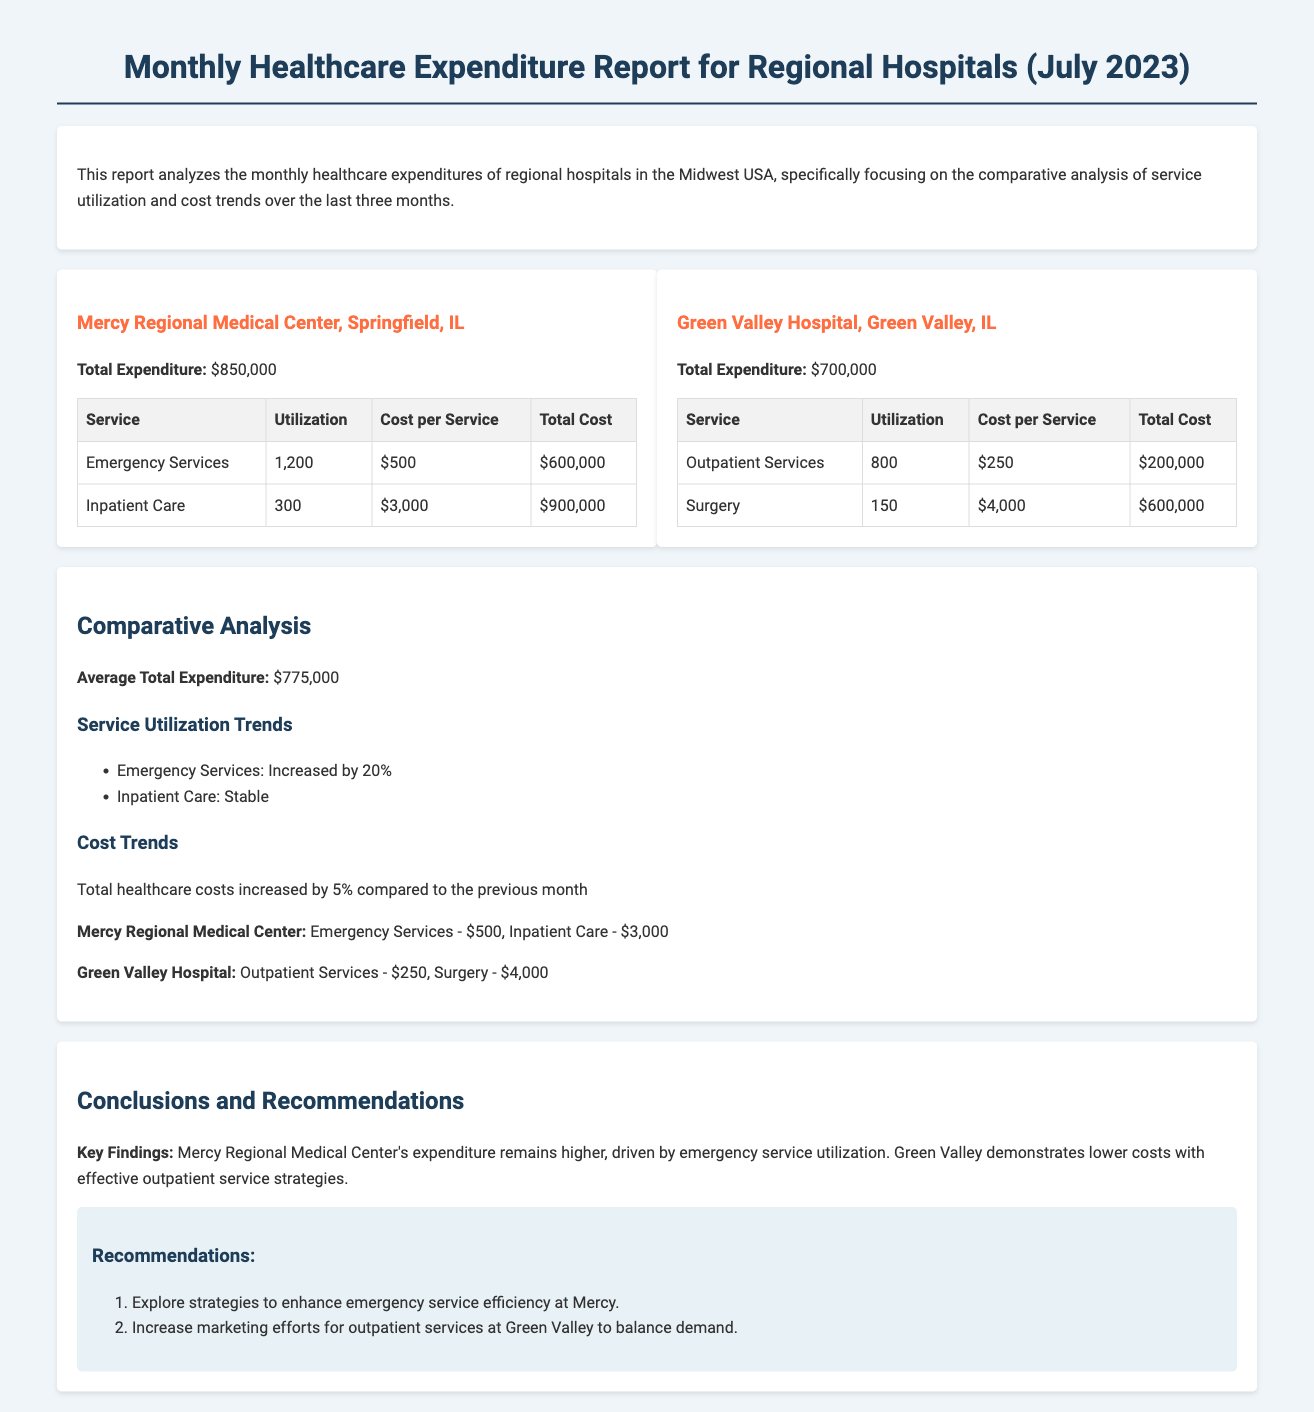What is the total expenditure for Mercy Regional Medical Center? The total expenditure is clearly stated in the document as $850,000 for Mercy Regional Medical Center.
Answer: $850,000 How many emergency services were utilized at Mercy Regional Medical Center? The number of emergency services utilized is provided in the table under the respective service, which is 1,200.
Answer: 1,200 What is the total cost for inpatient care at Mercy Regional Medical Center? The total cost for inpatient care is listed in the table, which adds up to $900,000.
Answer: $900,000 What service had the highest utilization at Green Valley Hospital? The highest utilization service at Green Valley Hospital, based on the table data, is Surgery with 150 utilizations.
Answer: Surgery What was the percentage increase in total healthcare costs compared to the previous month? The document summarizes this increase as 5%, indicating a growth in total healthcare costs.
Answer: 5% What key finding is noted about Green Valley Hospital's expenditure strategy? The report notes that Green Valley demonstrates lower costs with effective outpatient service strategies, emphasizing their economic efficiency.
Answer: Lower costs What are the two recommendations made for Mercy and Green Valley hospitals? The recommendations include enhancing emergency service efficiency at Mercy and increasing marketing efforts for outpatient services at Green Valley.
Answer: Enhance emergency service efficiency; Increase marketing efforts What month does this report cover? The report specifically analyzes expenditures for July 2023 as indicated in the title.
Answer: July 2023 What is the total expenditure for Green Valley Hospital? The total expenditure is mentioned in the document as $700,000 for Green Valley Hospital.
Answer: $700,000 